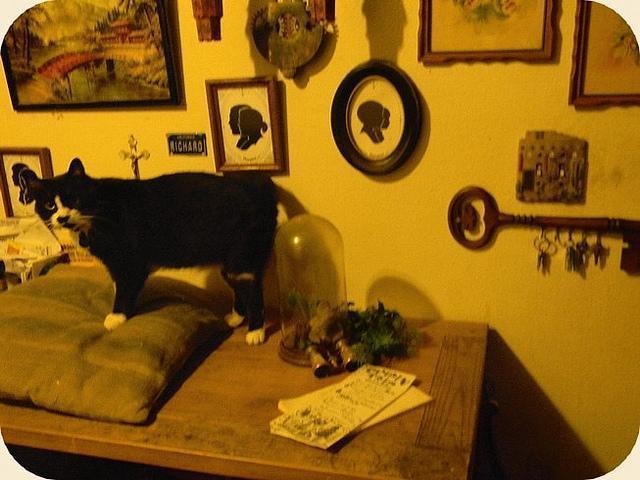How many cats are in the photo?
Give a very brief answer. 1. How many trains is there?
Give a very brief answer. 0. 